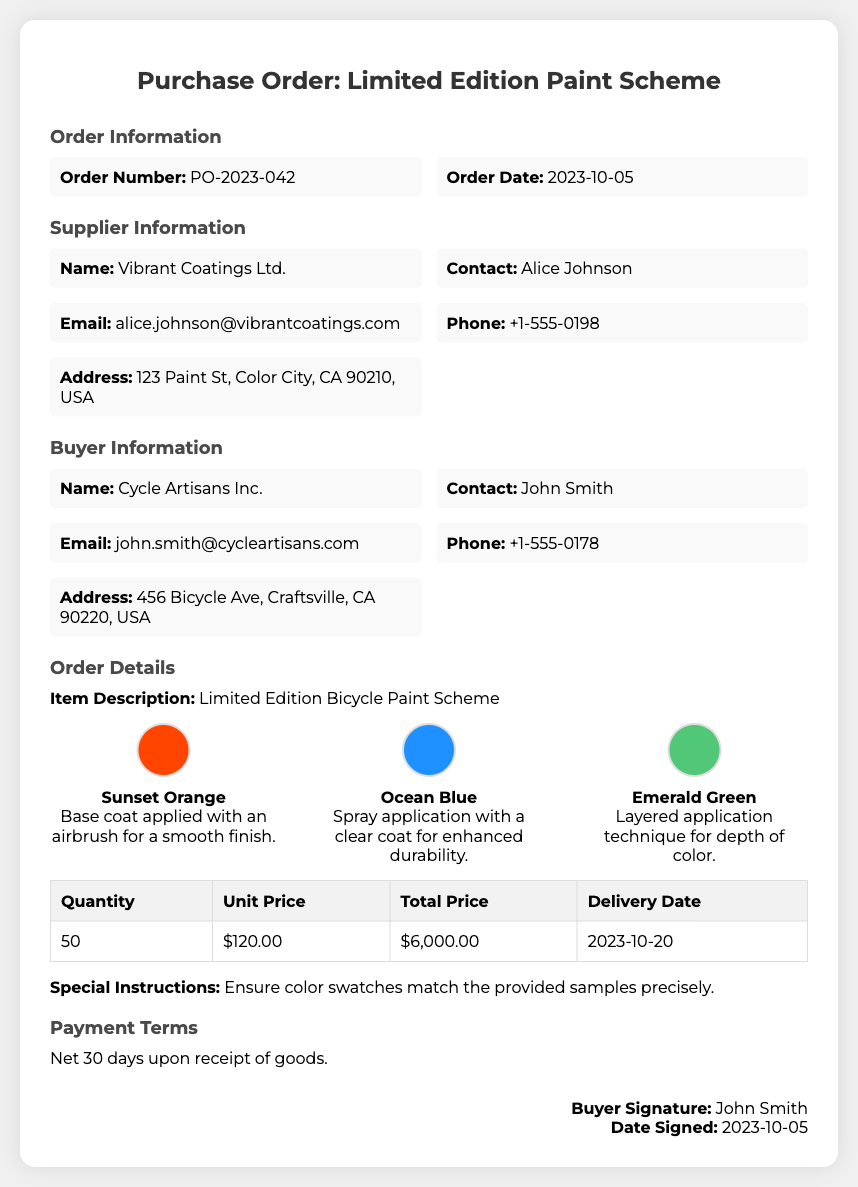What is the order number? The order number is specified in the document under Order Information as PO-2023-042.
Answer: PO-2023-042 Who is the supplier? The supplier is mentioned in the Supplier Information section as Vibrant Coatings Ltd.
Answer: Vibrant Coatings Ltd What color is described for the base coat? The document specifies Sunset Orange as the color for the base coat.
Answer: Sunset Orange What is the total price for the order? The total price is listed in the Order Details table as $6,000.00.
Answer: $6,000.00 When is the delivery date? The delivery date is provided in the Order Details table as 2023-10-20.
Answer: 2023-10-20 What technical application is used for Ocean Blue? The document describes the application for Ocean Blue as "Spray application with a clear coat for enhanced durability."
Answer: Spray application with a clear coat What is the quantity of the order? The quantity is specified in the Order Details table as 50.
Answer: 50 Who is the buyer's contact person? The buyer's contact person is mentioned as John Smith in the Buyer Information section.
Answer: John Smith What are the payment terms? The payment terms are outlined as "Net 30 days upon receipt of goods."
Answer: Net 30 days upon receipt of goods 